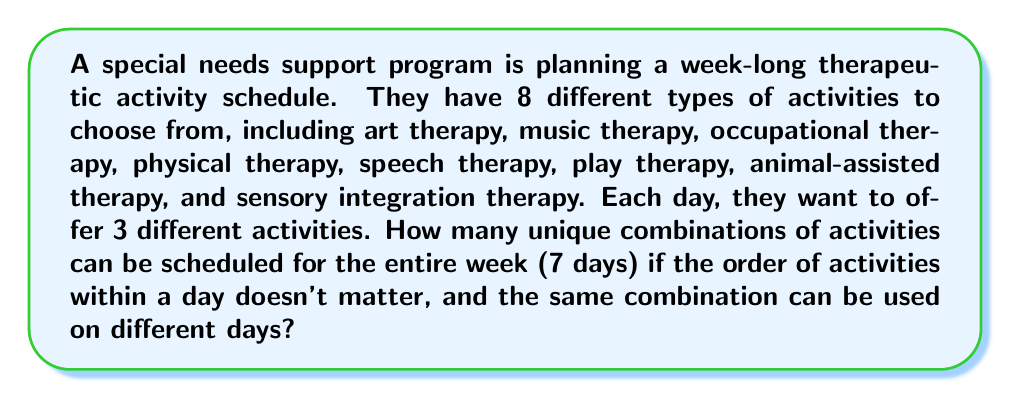Can you solve this math problem? Let's approach this step-by-step:

1) First, we need to calculate how many ways we can choose 3 activities out of 8 for a single day. This is a combination problem, as the order doesn't matter.

2) The formula for combinations is:

   $$C(n,r) = \frac{n!}{r!(n-r)!}$$

   Where $n$ is the total number of items to choose from, and $r$ is the number of items being chosen.

3) In this case, $n = 8$ (total activities) and $r = 3$ (activities per day).

4) Plugging these numbers into the formula:

   $$C(8,3) = \frac{8!}{3!(8-3)!} = \frac{8!}{3!5!}$$

5) Calculating this:
   
   $$\frac{8 * 7 * 6 * 5!}{(3 * 2 * 1) * 5!} = \frac{336}{6} = 56$$

6) So, there are 56 possible combinations of activities for a single day.

7) Now, we need to consider that this choice is made for each of the 7 days of the week. Since the same combination can be used on different days, this becomes a problem of choosing with replacement.

8) When choosing with replacement, we multiply the number of options for each choice. So we have 56 choices for each of the 7 days.

9) Therefore, the total number of possible schedules for the week is:

   $$56^7$$

10) Calculating this:
    
    $$56^7 = 4,398,046,511,104$$

Thus, there are 4,398,046,511,104 unique ways to schedule the activities for the week.
Answer: $56^7 = 4,398,046,511,104$ 